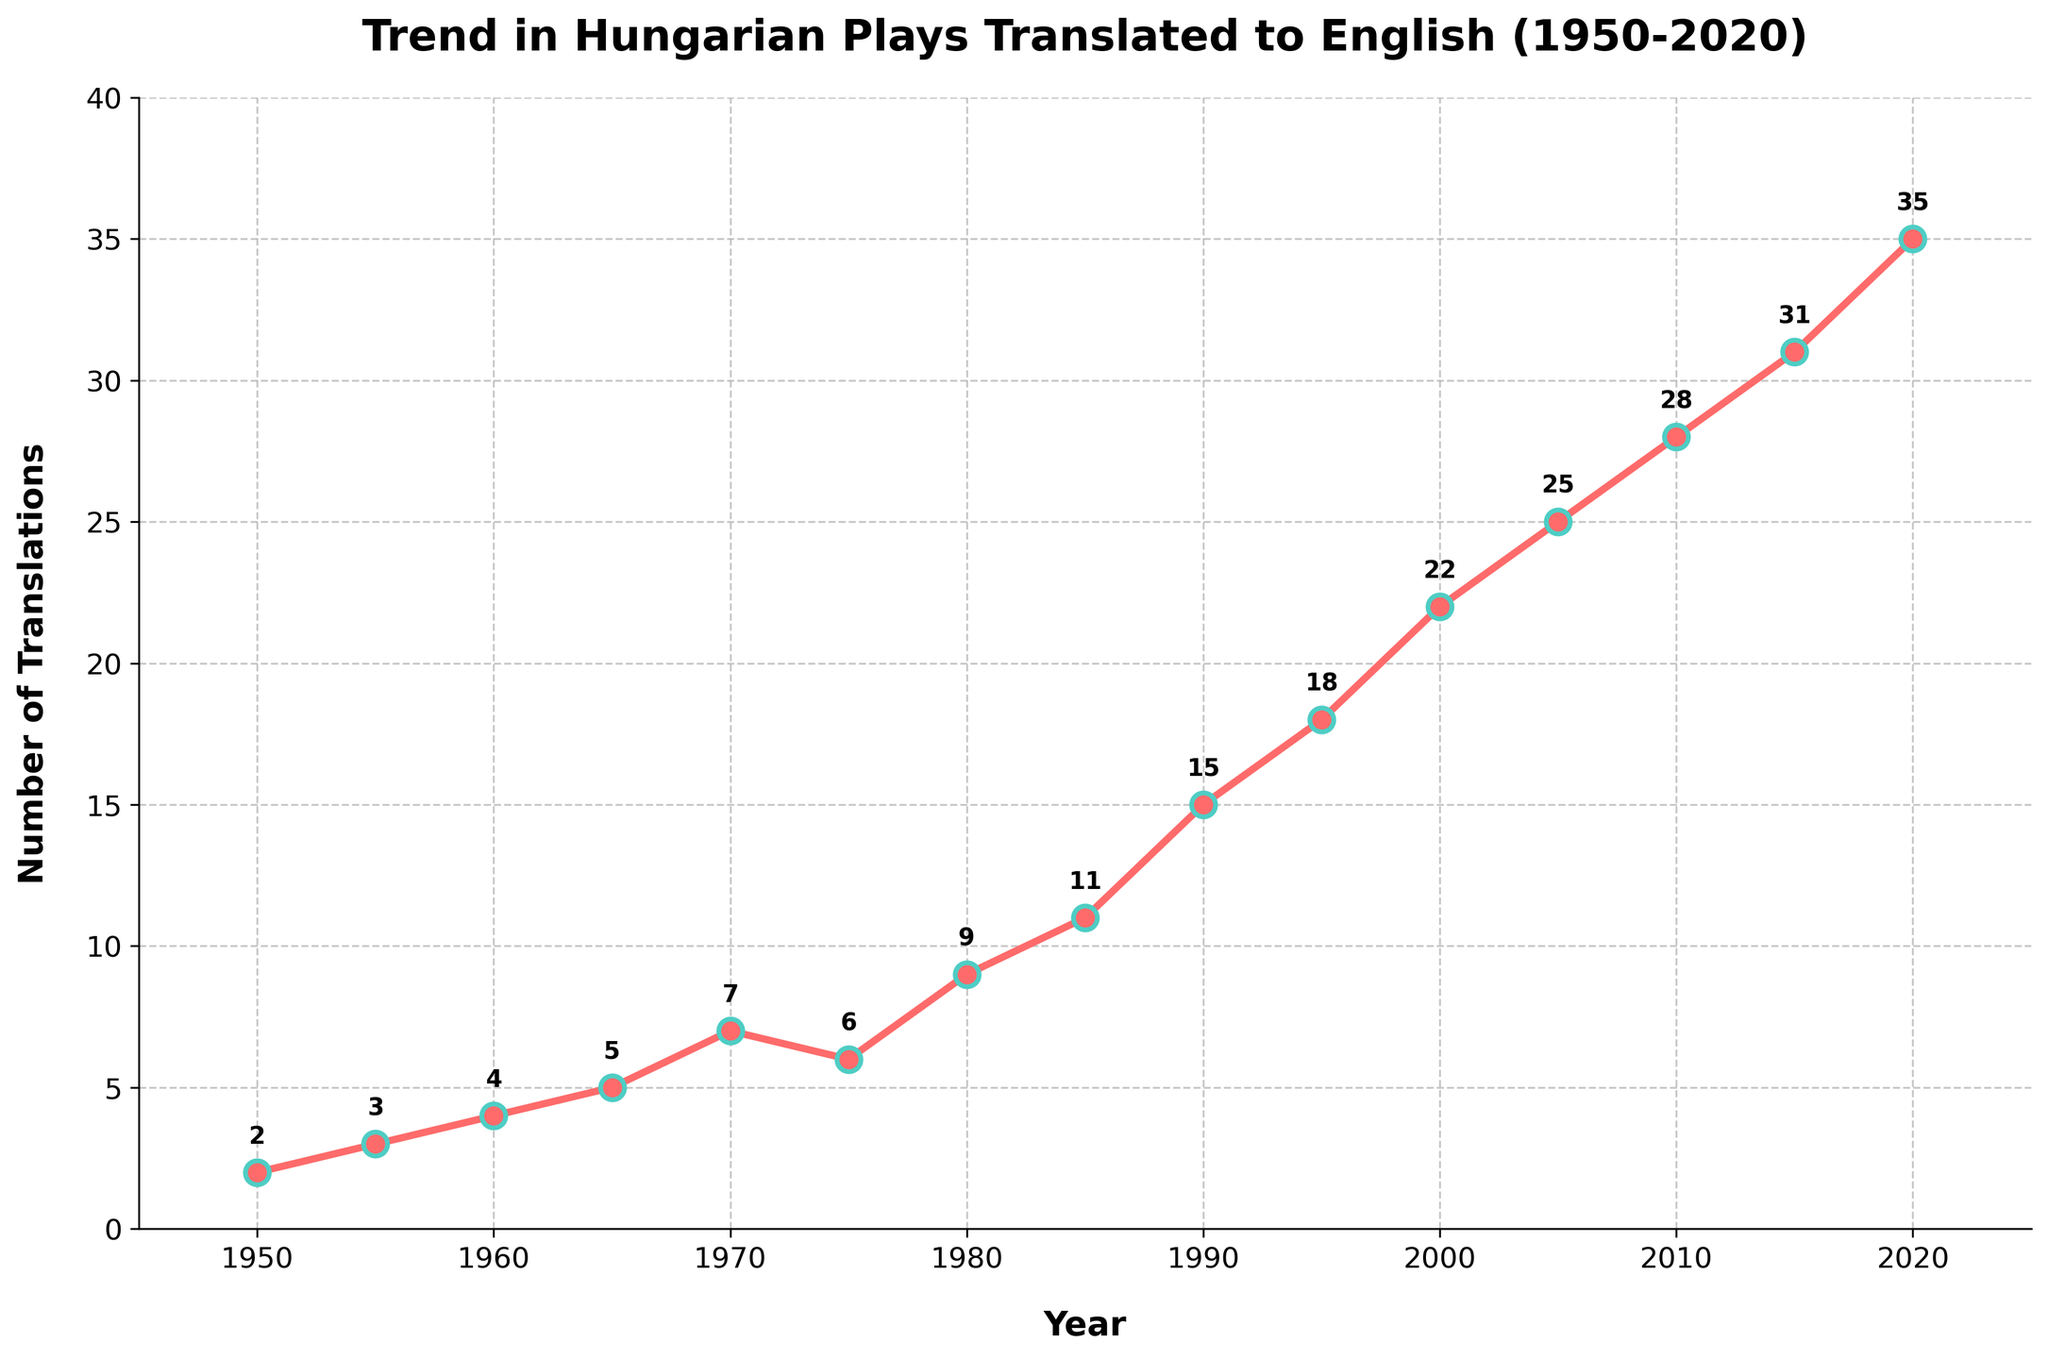How many translations were there in 1990? Look at the data point for the year 1990 on the chart.
Answer: 15 What is the total number of translations from 1950 to 2000? Sum the translations from each year between 1950 and 2000. The values are 2, 3, 4, 5, 7, 6, 9, 11, 15, 18, and 22. Adding these gives 2 + 3 + 4 + 5 + 7 + 6 + 9 + 11 + 15 + 18 + 22 = 102.
Answer: 102 In which decade did the largest increase in translations occur? Compare the translation counts at the end of each decade: 1950s (from 2 to 3 = +1), 1960s (from 3 to 4 = +1), 1970s (from 5 to 7 = +2), 1980s (from 7 to 11 = +4), 1990s (from 11 to 18 = +7), 2000s (from 18 to 25 = +7), 2010s (from 25 to 31 = +6). The largest increase was from 1990 to 2000 and 1980 to 1990 (both +7).
Answer: 1990s & 2000s Do the number of translations steadily increase, decrease, or fluctuate over time? Observe the trends of the line in the chart. The number of translations generally increases over time without significant decreases or fluctuations.
Answer: Increase What is the average number of translations per year between 1980 and 2020? Sum the translations from each year between 1980 and 2020: 9, 11, 15, 18, 22, 25, 28, 31, 35. The total sum is 9 + 11 + 15 + 18 + 22 + 25 + 28 + 31 + 35 = 194. There are 9 years, so the average is 194/9 ≈ 21.56.
Answer: 21.56 Which year had more translations, 1975 or 1980? Compare the data points for 1975 and 1980 on the chart. 1975 had 6 translations, and 1980 had 9 translations.
Answer: 1980 How many more translations were there in 2020 compared to 2000? Subtract the number of translations in 2000 from those in 2020: 35 - 22 = 13.
Answer: 13 What is the median number of translations between 1950 and 2020? Arrange the translation counts in ascending order: 2, 3, 4, 5, 6, 7, 9, 11, 15, 18, 22, 25, 28, 31, 35. The middle value is the 8th value since there are 15 numbers: 11.
Answer: 11 